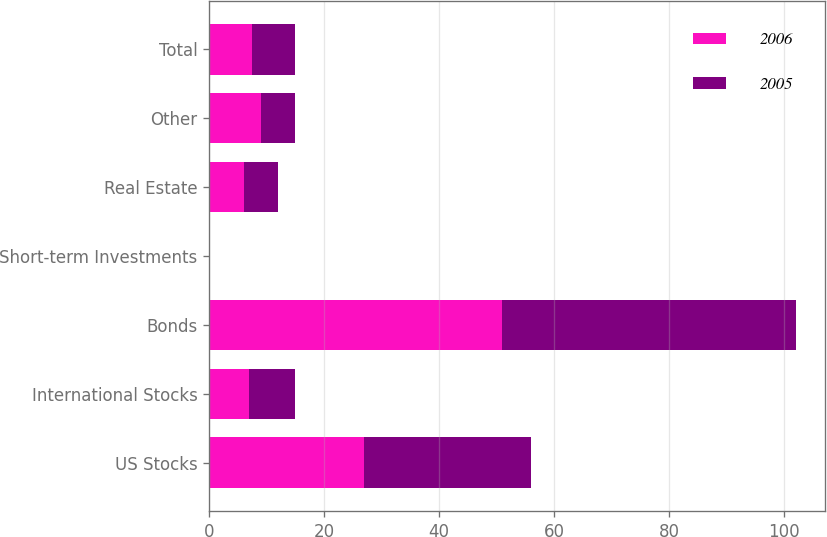Convert chart. <chart><loc_0><loc_0><loc_500><loc_500><stacked_bar_chart><ecel><fcel>US Stocks<fcel>International Stocks<fcel>Bonds<fcel>Short-term Investments<fcel>Real Estate<fcel>Other<fcel>Total<nl><fcel>2006<fcel>27<fcel>7<fcel>51<fcel>0<fcel>6<fcel>9<fcel>7.5<nl><fcel>2005<fcel>29<fcel>8<fcel>51<fcel>0<fcel>6<fcel>6<fcel>7.5<nl></chart> 